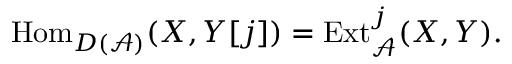Convert formula to latex. <formula><loc_0><loc_0><loc_500><loc_500>{ H o m } _ { D ( { \mathcal { A } } ) } ( X , Y [ j ] ) = { E x t } _ { \mathcal { A } } ^ { j } ( X , Y ) .</formula> 